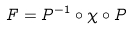Convert formula to latex. <formula><loc_0><loc_0><loc_500><loc_500>F = P ^ { - 1 } \circ \chi \circ P</formula> 